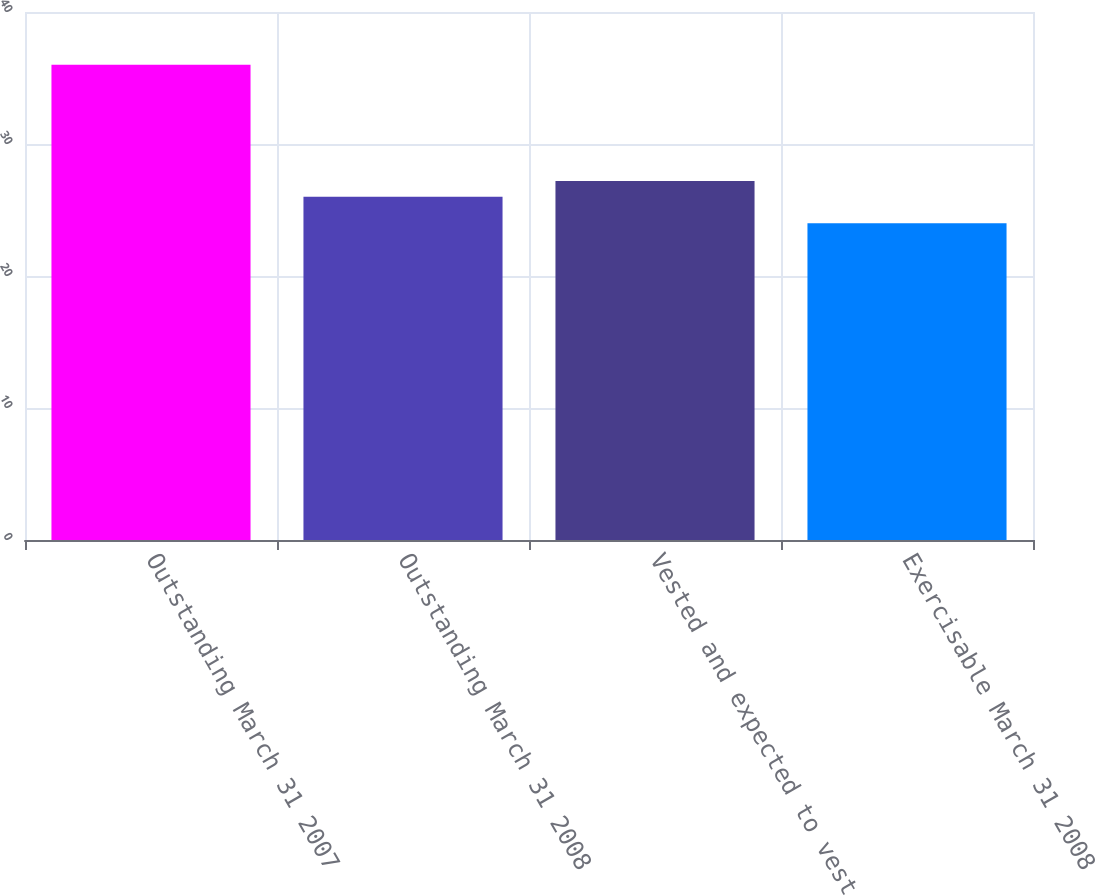<chart> <loc_0><loc_0><loc_500><loc_500><bar_chart><fcel>Outstanding March 31 2007<fcel>Outstanding March 31 2008<fcel>Vested and expected to vest<fcel>Exercisable March 31 2008<nl><fcel>36<fcel>26<fcel>27.2<fcel>24<nl></chart> 